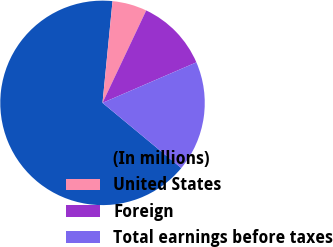<chart> <loc_0><loc_0><loc_500><loc_500><pie_chart><fcel>(In millions)<fcel>United States<fcel>Foreign<fcel>Total earnings before taxes<nl><fcel>65.56%<fcel>5.47%<fcel>11.48%<fcel>17.49%<nl></chart> 